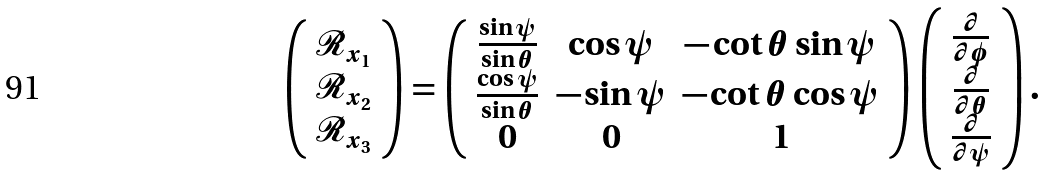<formula> <loc_0><loc_0><loc_500><loc_500>\left ( \begin{array} { c } \mathcal { R } _ { x _ { 1 } } \\ \mathcal { R } _ { x _ { 2 } } \\ \mathcal { R } _ { x _ { 3 } } \\ \end{array} \right ) = \left ( \begin{array} { c c c } \frac { \sin \psi } { \sin \theta } & \cos \psi & - \cot \theta \sin \psi \\ \frac { \cos \psi } { \sin \theta } & - \sin \psi & - \cot \theta \cos \psi \\ 0 & 0 & 1 \\ \end{array} \right ) \left ( \begin{array} { c } \frac { \partial } { \partial \phi } \\ \frac { \partial } { \partial \theta } \\ \frac { \partial } { \partial \psi } \\ \end{array} \right ) .</formula> 